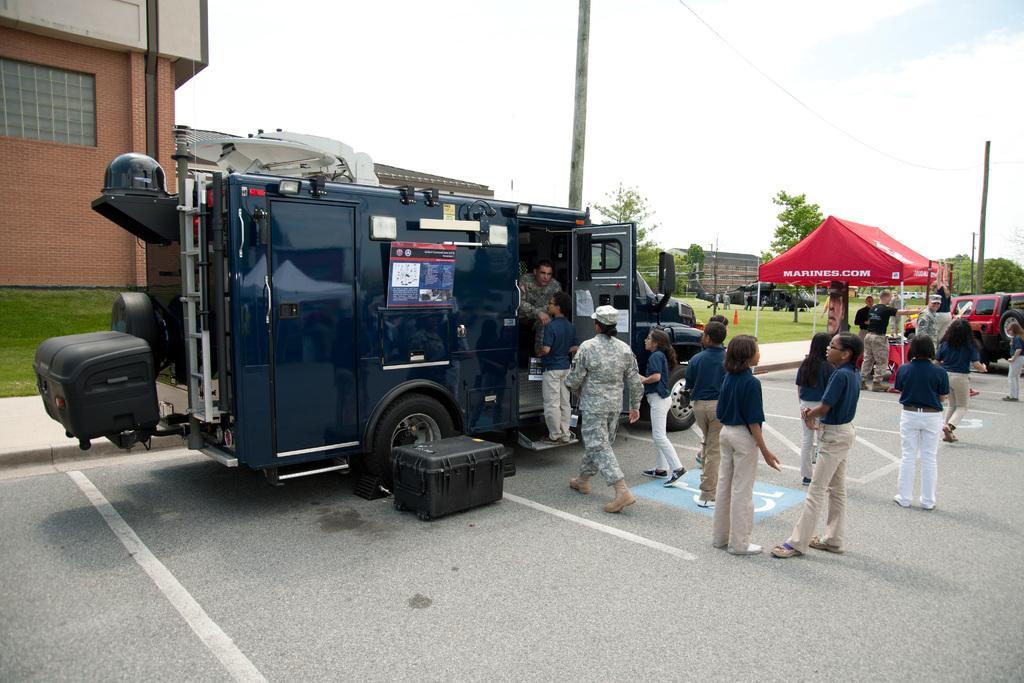How would you summarize this image in a sentence or two? In this picture we can see vehicles and a group of people standing on the road, box, tent, grass, buildings, trees, poles and in the background we can see the sky. 